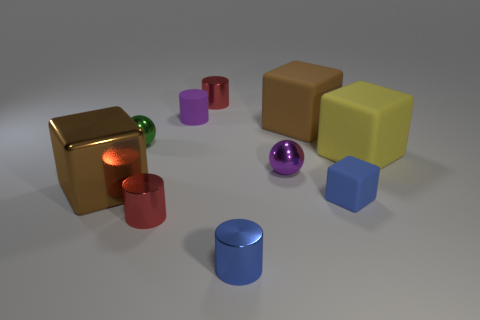What is the shape of the rubber thing that is the same color as the big shiny object?
Offer a terse response. Cube. Are there more small balls that are in front of the tiny matte block than tiny cyan cubes?
Provide a short and direct response. No. How many purple things are in front of the large brown matte object?
Ensure brevity in your answer.  1. Are there any purple metal things that have the same size as the purple matte cylinder?
Keep it short and to the point. Yes. There is a tiny object that is the same shape as the big brown shiny thing; what is its color?
Give a very brief answer. Blue. There is a brown object that is in front of the small green object; does it have the same size as the shiny cylinder behind the green metal thing?
Offer a terse response. No. Are there any other yellow objects of the same shape as the large shiny object?
Offer a terse response. Yes. Are there the same number of big cubes on the left side of the green ball and tiny blue matte things?
Your response must be concise. Yes. There is a purple ball; does it have the same size as the brown thing in front of the green thing?
Provide a short and direct response. No. How many tiny blue cylinders are the same material as the purple cylinder?
Offer a terse response. 0. 